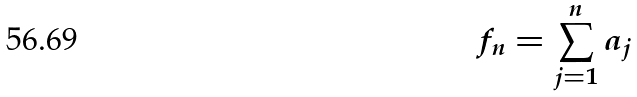Convert formula to latex. <formula><loc_0><loc_0><loc_500><loc_500>f _ { n } = \sum _ { j = 1 } ^ { n } a _ { j }</formula> 